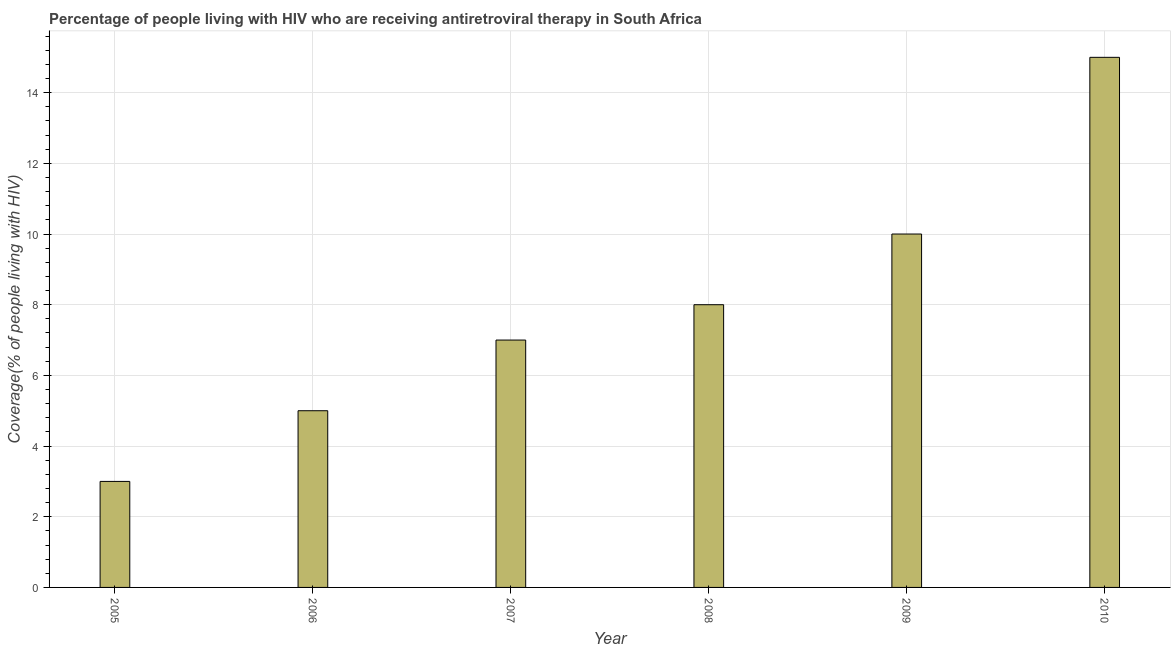Does the graph contain any zero values?
Keep it short and to the point. No. What is the title of the graph?
Make the answer very short. Percentage of people living with HIV who are receiving antiretroviral therapy in South Africa. What is the label or title of the X-axis?
Make the answer very short. Year. What is the label or title of the Y-axis?
Ensure brevity in your answer.  Coverage(% of people living with HIV). In which year was the antiretroviral therapy coverage maximum?
Offer a terse response. 2010. What is the average antiretroviral therapy coverage per year?
Provide a succinct answer. 8. What is the median antiretroviral therapy coverage?
Your answer should be very brief. 7.5. In how many years, is the antiretroviral therapy coverage greater than 2.4 %?
Ensure brevity in your answer.  6. What is the ratio of the antiretroviral therapy coverage in 2006 to that in 2008?
Ensure brevity in your answer.  0.62. What is the difference between the highest and the second highest antiretroviral therapy coverage?
Offer a terse response. 5. In how many years, is the antiretroviral therapy coverage greater than the average antiretroviral therapy coverage taken over all years?
Make the answer very short. 2. How many bars are there?
Make the answer very short. 6. What is the Coverage(% of people living with HIV) in 2006?
Your response must be concise. 5. What is the Coverage(% of people living with HIV) in 2007?
Ensure brevity in your answer.  7. What is the Coverage(% of people living with HIV) of 2009?
Your answer should be compact. 10. What is the Coverage(% of people living with HIV) in 2010?
Your answer should be compact. 15. What is the difference between the Coverage(% of people living with HIV) in 2005 and 2006?
Provide a short and direct response. -2. What is the difference between the Coverage(% of people living with HIV) in 2005 and 2007?
Provide a succinct answer. -4. What is the difference between the Coverage(% of people living with HIV) in 2005 and 2010?
Make the answer very short. -12. What is the difference between the Coverage(% of people living with HIV) in 2006 and 2007?
Make the answer very short. -2. What is the difference between the Coverage(% of people living with HIV) in 2007 and 2008?
Your response must be concise. -1. What is the difference between the Coverage(% of people living with HIV) in 2007 and 2009?
Your answer should be very brief. -3. What is the difference between the Coverage(% of people living with HIV) in 2008 and 2010?
Offer a terse response. -7. What is the ratio of the Coverage(% of people living with HIV) in 2005 to that in 2007?
Your response must be concise. 0.43. What is the ratio of the Coverage(% of people living with HIV) in 2005 to that in 2008?
Provide a succinct answer. 0.38. What is the ratio of the Coverage(% of people living with HIV) in 2005 to that in 2010?
Your answer should be compact. 0.2. What is the ratio of the Coverage(% of people living with HIV) in 2006 to that in 2007?
Give a very brief answer. 0.71. What is the ratio of the Coverage(% of people living with HIV) in 2006 to that in 2008?
Your response must be concise. 0.62. What is the ratio of the Coverage(% of people living with HIV) in 2006 to that in 2010?
Provide a succinct answer. 0.33. What is the ratio of the Coverage(% of people living with HIV) in 2007 to that in 2008?
Give a very brief answer. 0.88. What is the ratio of the Coverage(% of people living with HIV) in 2007 to that in 2009?
Make the answer very short. 0.7. What is the ratio of the Coverage(% of people living with HIV) in 2007 to that in 2010?
Offer a very short reply. 0.47. What is the ratio of the Coverage(% of people living with HIV) in 2008 to that in 2009?
Provide a succinct answer. 0.8. What is the ratio of the Coverage(% of people living with HIV) in 2008 to that in 2010?
Give a very brief answer. 0.53. What is the ratio of the Coverage(% of people living with HIV) in 2009 to that in 2010?
Provide a succinct answer. 0.67. 